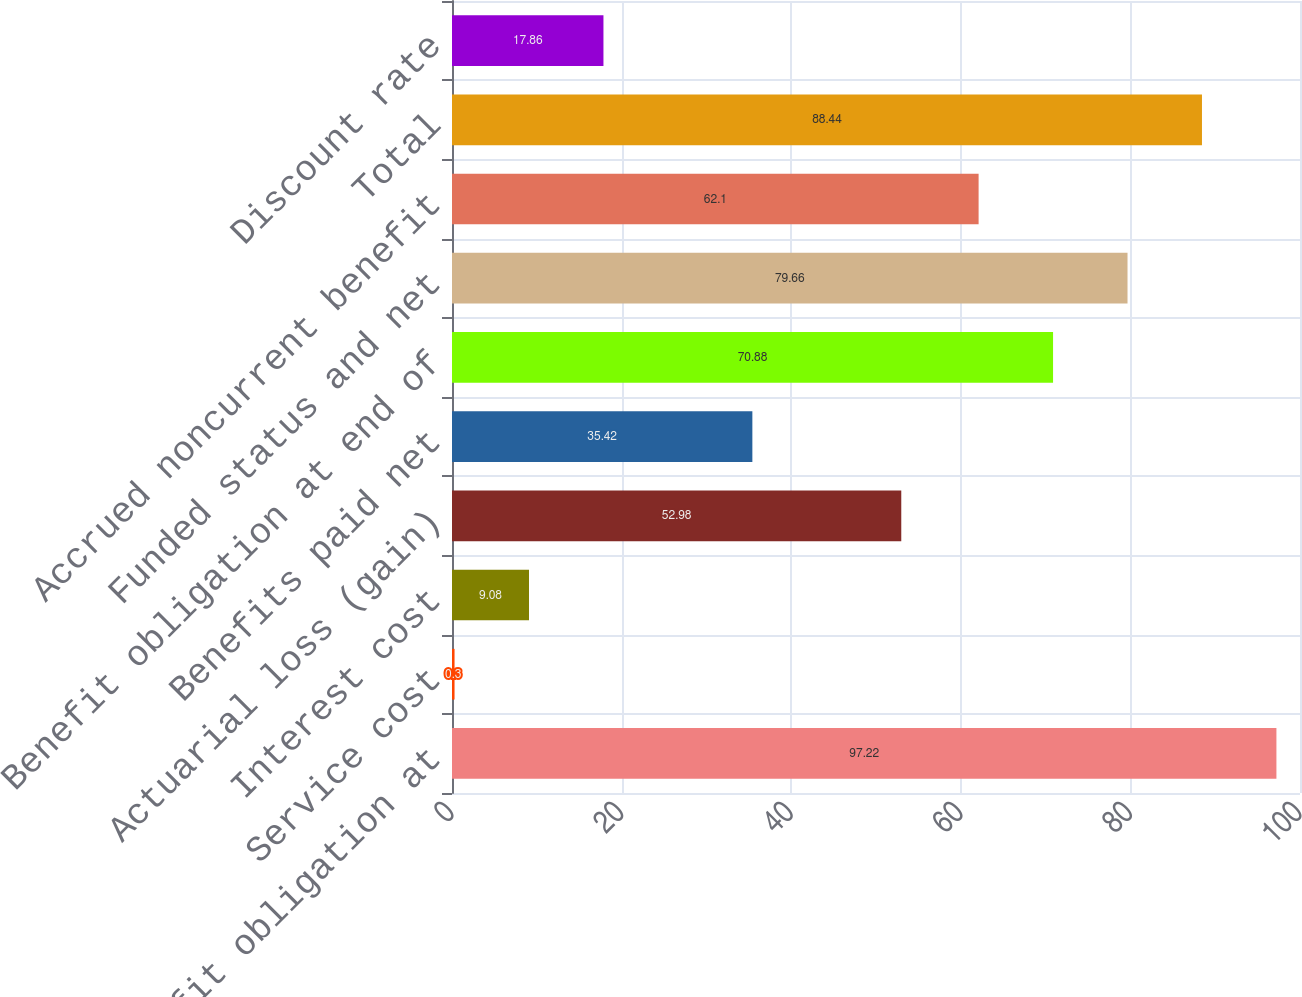Convert chart to OTSL. <chart><loc_0><loc_0><loc_500><loc_500><bar_chart><fcel>Benefit obligation at<fcel>Service cost<fcel>Interest cost<fcel>Actuarial loss (gain)<fcel>Benefits paid net<fcel>Benefit obligation at end of<fcel>Funded status and net<fcel>Accrued noncurrent benefit<fcel>Total<fcel>Discount rate<nl><fcel>97.22<fcel>0.3<fcel>9.08<fcel>52.98<fcel>35.42<fcel>70.88<fcel>79.66<fcel>62.1<fcel>88.44<fcel>17.86<nl></chart> 